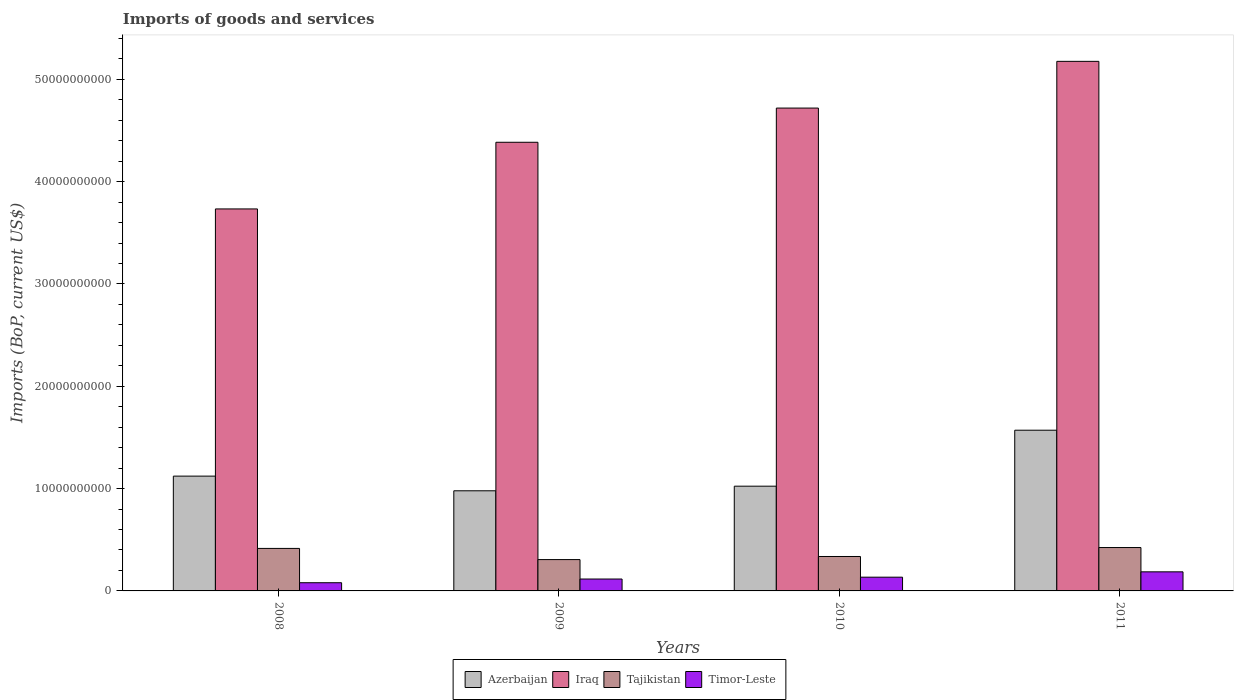How many groups of bars are there?
Provide a succinct answer. 4. Are the number of bars per tick equal to the number of legend labels?
Your response must be concise. Yes. Are the number of bars on each tick of the X-axis equal?
Make the answer very short. Yes. What is the label of the 4th group of bars from the left?
Your answer should be compact. 2011. In how many cases, is the number of bars for a given year not equal to the number of legend labels?
Provide a short and direct response. 0. What is the amount spent on imports in Tajikistan in 2008?
Make the answer very short. 4.15e+09. Across all years, what is the maximum amount spent on imports in Azerbaijan?
Your response must be concise. 1.57e+1. Across all years, what is the minimum amount spent on imports in Azerbaijan?
Your response must be concise. 9.79e+09. In which year was the amount spent on imports in Iraq minimum?
Your response must be concise. 2008. What is the total amount spent on imports in Tajikistan in the graph?
Ensure brevity in your answer.  1.48e+1. What is the difference between the amount spent on imports in Timor-Leste in 2009 and that in 2011?
Your answer should be compact. -7.03e+08. What is the difference between the amount spent on imports in Tajikistan in 2011 and the amount spent on imports in Azerbaijan in 2008?
Give a very brief answer. -6.98e+09. What is the average amount spent on imports in Azerbaijan per year?
Give a very brief answer. 1.17e+1. In the year 2011, what is the difference between the amount spent on imports in Timor-Leste and amount spent on imports in Tajikistan?
Give a very brief answer. -2.37e+09. What is the ratio of the amount spent on imports in Timor-Leste in 2008 to that in 2010?
Provide a short and direct response. 0.6. Is the difference between the amount spent on imports in Timor-Leste in 2010 and 2011 greater than the difference between the amount spent on imports in Tajikistan in 2010 and 2011?
Offer a very short reply. Yes. What is the difference between the highest and the second highest amount spent on imports in Tajikistan?
Give a very brief answer. 8.48e+07. What is the difference between the highest and the lowest amount spent on imports in Azerbaijan?
Your answer should be compact. 5.92e+09. In how many years, is the amount spent on imports in Iraq greater than the average amount spent on imports in Iraq taken over all years?
Your response must be concise. 2. Is it the case that in every year, the sum of the amount spent on imports in Iraq and amount spent on imports in Azerbaijan is greater than the sum of amount spent on imports in Tajikistan and amount spent on imports in Timor-Leste?
Provide a short and direct response. Yes. What does the 2nd bar from the left in 2011 represents?
Provide a succinct answer. Iraq. What does the 3rd bar from the right in 2010 represents?
Your response must be concise. Iraq. Are all the bars in the graph horizontal?
Your response must be concise. No. Are the values on the major ticks of Y-axis written in scientific E-notation?
Your response must be concise. No. Does the graph contain any zero values?
Keep it short and to the point. No. Where does the legend appear in the graph?
Your answer should be compact. Bottom center. How many legend labels are there?
Offer a terse response. 4. What is the title of the graph?
Offer a very short reply. Imports of goods and services. Does "Kiribati" appear as one of the legend labels in the graph?
Give a very brief answer. No. What is the label or title of the Y-axis?
Make the answer very short. Imports (BoP, current US$). What is the Imports (BoP, current US$) in Azerbaijan in 2008?
Your answer should be compact. 1.12e+1. What is the Imports (BoP, current US$) of Iraq in 2008?
Your response must be concise. 3.73e+1. What is the Imports (BoP, current US$) in Tajikistan in 2008?
Offer a terse response. 4.15e+09. What is the Imports (BoP, current US$) in Timor-Leste in 2008?
Offer a terse response. 8.01e+08. What is the Imports (BoP, current US$) in Azerbaijan in 2009?
Your response must be concise. 9.79e+09. What is the Imports (BoP, current US$) of Iraq in 2009?
Offer a very short reply. 4.38e+1. What is the Imports (BoP, current US$) in Tajikistan in 2009?
Your response must be concise. 3.06e+09. What is the Imports (BoP, current US$) in Timor-Leste in 2009?
Your answer should be compact. 1.16e+09. What is the Imports (BoP, current US$) of Azerbaijan in 2010?
Offer a very short reply. 1.02e+1. What is the Imports (BoP, current US$) of Iraq in 2010?
Provide a succinct answer. 4.72e+1. What is the Imports (BoP, current US$) in Tajikistan in 2010?
Your response must be concise. 3.36e+09. What is the Imports (BoP, current US$) of Timor-Leste in 2010?
Offer a terse response. 1.34e+09. What is the Imports (BoP, current US$) of Azerbaijan in 2011?
Provide a succinct answer. 1.57e+1. What is the Imports (BoP, current US$) in Iraq in 2011?
Offer a terse response. 5.18e+1. What is the Imports (BoP, current US$) in Tajikistan in 2011?
Your answer should be very brief. 4.24e+09. What is the Imports (BoP, current US$) of Timor-Leste in 2011?
Offer a very short reply. 1.87e+09. Across all years, what is the maximum Imports (BoP, current US$) of Azerbaijan?
Keep it short and to the point. 1.57e+1. Across all years, what is the maximum Imports (BoP, current US$) of Iraq?
Provide a short and direct response. 5.18e+1. Across all years, what is the maximum Imports (BoP, current US$) in Tajikistan?
Give a very brief answer. 4.24e+09. Across all years, what is the maximum Imports (BoP, current US$) of Timor-Leste?
Offer a terse response. 1.87e+09. Across all years, what is the minimum Imports (BoP, current US$) in Azerbaijan?
Keep it short and to the point. 9.79e+09. Across all years, what is the minimum Imports (BoP, current US$) of Iraq?
Ensure brevity in your answer.  3.73e+1. Across all years, what is the minimum Imports (BoP, current US$) of Tajikistan?
Keep it short and to the point. 3.06e+09. Across all years, what is the minimum Imports (BoP, current US$) of Timor-Leste?
Your answer should be compact. 8.01e+08. What is the total Imports (BoP, current US$) in Azerbaijan in the graph?
Offer a terse response. 4.70e+1. What is the total Imports (BoP, current US$) of Iraq in the graph?
Offer a very short reply. 1.80e+11. What is the total Imports (BoP, current US$) of Tajikistan in the graph?
Offer a terse response. 1.48e+1. What is the total Imports (BoP, current US$) in Timor-Leste in the graph?
Offer a very short reply. 5.17e+09. What is the difference between the Imports (BoP, current US$) in Azerbaijan in 2008 and that in 2009?
Offer a terse response. 1.43e+09. What is the difference between the Imports (BoP, current US$) in Iraq in 2008 and that in 2009?
Provide a succinct answer. -6.51e+09. What is the difference between the Imports (BoP, current US$) in Tajikistan in 2008 and that in 2009?
Your answer should be very brief. 1.09e+09. What is the difference between the Imports (BoP, current US$) of Timor-Leste in 2008 and that in 2009?
Offer a very short reply. -3.62e+08. What is the difference between the Imports (BoP, current US$) of Azerbaijan in 2008 and that in 2010?
Offer a terse response. 9.84e+08. What is the difference between the Imports (BoP, current US$) in Iraq in 2008 and that in 2010?
Provide a succinct answer. -9.86e+09. What is the difference between the Imports (BoP, current US$) of Tajikistan in 2008 and that in 2010?
Provide a succinct answer. 7.90e+08. What is the difference between the Imports (BoP, current US$) of Timor-Leste in 2008 and that in 2010?
Your answer should be compact. -5.42e+08. What is the difference between the Imports (BoP, current US$) of Azerbaijan in 2008 and that in 2011?
Give a very brief answer. -4.49e+09. What is the difference between the Imports (BoP, current US$) in Iraq in 2008 and that in 2011?
Offer a very short reply. -1.44e+1. What is the difference between the Imports (BoP, current US$) in Tajikistan in 2008 and that in 2011?
Offer a very short reply. -8.48e+07. What is the difference between the Imports (BoP, current US$) in Timor-Leste in 2008 and that in 2011?
Your answer should be compact. -1.06e+09. What is the difference between the Imports (BoP, current US$) of Azerbaijan in 2009 and that in 2010?
Offer a very short reply. -4.49e+08. What is the difference between the Imports (BoP, current US$) in Iraq in 2009 and that in 2010?
Your answer should be compact. -3.34e+09. What is the difference between the Imports (BoP, current US$) of Tajikistan in 2009 and that in 2010?
Offer a terse response. -3.02e+08. What is the difference between the Imports (BoP, current US$) of Timor-Leste in 2009 and that in 2010?
Your answer should be compact. -1.80e+08. What is the difference between the Imports (BoP, current US$) in Azerbaijan in 2009 and that in 2011?
Provide a short and direct response. -5.92e+09. What is the difference between the Imports (BoP, current US$) of Iraq in 2009 and that in 2011?
Keep it short and to the point. -7.91e+09. What is the difference between the Imports (BoP, current US$) in Tajikistan in 2009 and that in 2011?
Offer a terse response. -1.18e+09. What is the difference between the Imports (BoP, current US$) of Timor-Leste in 2009 and that in 2011?
Offer a very short reply. -7.03e+08. What is the difference between the Imports (BoP, current US$) of Azerbaijan in 2010 and that in 2011?
Your answer should be very brief. -5.47e+09. What is the difference between the Imports (BoP, current US$) in Iraq in 2010 and that in 2011?
Your response must be concise. -4.57e+09. What is the difference between the Imports (BoP, current US$) in Tajikistan in 2010 and that in 2011?
Offer a terse response. -8.75e+08. What is the difference between the Imports (BoP, current US$) of Timor-Leste in 2010 and that in 2011?
Offer a terse response. -5.23e+08. What is the difference between the Imports (BoP, current US$) in Azerbaijan in 2008 and the Imports (BoP, current US$) in Iraq in 2009?
Provide a short and direct response. -3.26e+1. What is the difference between the Imports (BoP, current US$) in Azerbaijan in 2008 and the Imports (BoP, current US$) in Tajikistan in 2009?
Provide a short and direct response. 8.16e+09. What is the difference between the Imports (BoP, current US$) of Azerbaijan in 2008 and the Imports (BoP, current US$) of Timor-Leste in 2009?
Make the answer very short. 1.01e+1. What is the difference between the Imports (BoP, current US$) of Iraq in 2008 and the Imports (BoP, current US$) of Tajikistan in 2009?
Make the answer very short. 3.43e+1. What is the difference between the Imports (BoP, current US$) in Iraq in 2008 and the Imports (BoP, current US$) in Timor-Leste in 2009?
Make the answer very short. 3.62e+1. What is the difference between the Imports (BoP, current US$) of Tajikistan in 2008 and the Imports (BoP, current US$) of Timor-Leste in 2009?
Make the answer very short. 2.99e+09. What is the difference between the Imports (BoP, current US$) in Azerbaijan in 2008 and the Imports (BoP, current US$) in Iraq in 2010?
Your response must be concise. -3.60e+1. What is the difference between the Imports (BoP, current US$) of Azerbaijan in 2008 and the Imports (BoP, current US$) of Tajikistan in 2010?
Offer a very short reply. 7.86e+09. What is the difference between the Imports (BoP, current US$) of Azerbaijan in 2008 and the Imports (BoP, current US$) of Timor-Leste in 2010?
Keep it short and to the point. 9.88e+09. What is the difference between the Imports (BoP, current US$) of Iraq in 2008 and the Imports (BoP, current US$) of Tajikistan in 2010?
Ensure brevity in your answer.  3.40e+1. What is the difference between the Imports (BoP, current US$) of Iraq in 2008 and the Imports (BoP, current US$) of Timor-Leste in 2010?
Provide a short and direct response. 3.60e+1. What is the difference between the Imports (BoP, current US$) of Tajikistan in 2008 and the Imports (BoP, current US$) of Timor-Leste in 2010?
Keep it short and to the point. 2.81e+09. What is the difference between the Imports (BoP, current US$) of Azerbaijan in 2008 and the Imports (BoP, current US$) of Iraq in 2011?
Provide a short and direct response. -4.05e+1. What is the difference between the Imports (BoP, current US$) in Azerbaijan in 2008 and the Imports (BoP, current US$) in Tajikistan in 2011?
Offer a very short reply. 6.98e+09. What is the difference between the Imports (BoP, current US$) in Azerbaijan in 2008 and the Imports (BoP, current US$) in Timor-Leste in 2011?
Make the answer very short. 9.36e+09. What is the difference between the Imports (BoP, current US$) of Iraq in 2008 and the Imports (BoP, current US$) of Tajikistan in 2011?
Provide a short and direct response. 3.31e+1. What is the difference between the Imports (BoP, current US$) in Iraq in 2008 and the Imports (BoP, current US$) in Timor-Leste in 2011?
Keep it short and to the point. 3.55e+1. What is the difference between the Imports (BoP, current US$) in Tajikistan in 2008 and the Imports (BoP, current US$) in Timor-Leste in 2011?
Your answer should be very brief. 2.29e+09. What is the difference between the Imports (BoP, current US$) in Azerbaijan in 2009 and the Imports (BoP, current US$) in Iraq in 2010?
Your answer should be compact. -3.74e+1. What is the difference between the Imports (BoP, current US$) of Azerbaijan in 2009 and the Imports (BoP, current US$) of Tajikistan in 2010?
Give a very brief answer. 6.42e+09. What is the difference between the Imports (BoP, current US$) in Azerbaijan in 2009 and the Imports (BoP, current US$) in Timor-Leste in 2010?
Ensure brevity in your answer.  8.44e+09. What is the difference between the Imports (BoP, current US$) of Iraq in 2009 and the Imports (BoP, current US$) of Tajikistan in 2010?
Make the answer very short. 4.05e+1. What is the difference between the Imports (BoP, current US$) in Iraq in 2009 and the Imports (BoP, current US$) in Timor-Leste in 2010?
Give a very brief answer. 4.25e+1. What is the difference between the Imports (BoP, current US$) of Tajikistan in 2009 and the Imports (BoP, current US$) of Timor-Leste in 2010?
Provide a short and direct response. 1.72e+09. What is the difference between the Imports (BoP, current US$) of Azerbaijan in 2009 and the Imports (BoP, current US$) of Iraq in 2011?
Ensure brevity in your answer.  -4.20e+1. What is the difference between the Imports (BoP, current US$) of Azerbaijan in 2009 and the Imports (BoP, current US$) of Tajikistan in 2011?
Offer a terse response. 5.55e+09. What is the difference between the Imports (BoP, current US$) of Azerbaijan in 2009 and the Imports (BoP, current US$) of Timor-Leste in 2011?
Keep it short and to the point. 7.92e+09. What is the difference between the Imports (BoP, current US$) in Iraq in 2009 and the Imports (BoP, current US$) in Tajikistan in 2011?
Provide a short and direct response. 3.96e+1. What is the difference between the Imports (BoP, current US$) of Iraq in 2009 and the Imports (BoP, current US$) of Timor-Leste in 2011?
Your response must be concise. 4.20e+1. What is the difference between the Imports (BoP, current US$) in Tajikistan in 2009 and the Imports (BoP, current US$) in Timor-Leste in 2011?
Your answer should be compact. 1.20e+09. What is the difference between the Imports (BoP, current US$) in Azerbaijan in 2010 and the Imports (BoP, current US$) in Iraq in 2011?
Provide a short and direct response. -4.15e+1. What is the difference between the Imports (BoP, current US$) in Azerbaijan in 2010 and the Imports (BoP, current US$) in Tajikistan in 2011?
Your response must be concise. 6.00e+09. What is the difference between the Imports (BoP, current US$) of Azerbaijan in 2010 and the Imports (BoP, current US$) of Timor-Leste in 2011?
Give a very brief answer. 8.37e+09. What is the difference between the Imports (BoP, current US$) of Iraq in 2010 and the Imports (BoP, current US$) of Tajikistan in 2011?
Give a very brief answer. 4.30e+1. What is the difference between the Imports (BoP, current US$) in Iraq in 2010 and the Imports (BoP, current US$) in Timor-Leste in 2011?
Give a very brief answer. 4.53e+1. What is the difference between the Imports (BoP, current US$) in Tajikistan in 2010 and the Imports (BoP, current US$) in Timor-Leste in 2011?
Your answer should be compact. 1.50e+09. What is the average Imports (BoP, current US$) of Azerbaijan per year?
Provide a short and direct response. 1.17e+1. What is the average Imports (BoP, current US$) in Iraq per year?
Your answer should be very brief. 4.50e+1. What is the average Imports (BoP, current US$) of Tajikistan per year?
Offer a very short reply. 3.71e+09. What is the average Imports (BoP, current US$) of Timor-Leste per year?
Make the answer very short. 1.29e+09. In the year 2008, what is the difference between the Imports (BoP, current US$) in Azerbaijan and Imports (BoP, current US$) in Iraq?
Your answer should be compact. -2.61e+1. In the year 2008, what is the difference between the Imports (BoP, current US$) in Azerbaijan and Imports (BoP, current US$) in Tajikistan?
Offer a very short reply. 7.07e+09. In the year 2008, what is the difference between the Imports (BoP, current US$) of Azerbaijan and Imports (BoP, current US$) of Timor-Leste?
Offer a terse response. 1.04e+1. In the year 2008, what is the difference between the Imports (BoP, current US$) of Iraq and Imports (BoP, current US$) of Tajikistan?
Give a very brief answer. 3.32e+1. In the year 2008, what is the difference between the Imports (BoP, current US$) of Iraq and Imports (BoP, current US$) of Timor-Leste?
Provide a short and direct response. 3.65e+1. In the year 2008, what is the difference between the Imports (BoP, current US$) in Tajikistan and Imports (BoP, current US$) in Timor-Leste?
Make the answer very short. 3.35e+09. In the year 2009, what is the difference between the Imports (BoP, current US$) in Azerbaijan and Imports (BoP, current US$) in Iraq?
Your answer should be very brief. -3.41e+1. In the year 2009, what is the difference between the Imports (BoP, current US$) in Azerbaijan and Imports (BoP, current US$) in Tajikistan?
Your answer should be very brief. 6.72e+09. In the year 2009, what is the difference between the Imports (BoP, current US$) of Azerbaijan and Imports (BoP, current US$) of Timor-Leste?
Give a very brief answer. 8.62e+09. In the year 2009, what is the difference between the Imports (BoP, current US$) in Iraq and Imports (BoP, current US$) in Tajikistan?
Provide a short and direct response. 4.08e+1. In the year 2009, what is the difference between the Imports (BoP, current US$) of Iraq and Imports (BoP, current US$) of Timor-Leste?
Keep it short and to the point. 4.27e+1. In the year 2009, what is the difference between the Imports (BoP, current US$) of Tajikistan and Imports (BoP, current US$) of Timor-Leste?
Keep it short and to the point. 1.90e+09. In the year 2010, what is the difference between the Imports (BoP, current US$) in Azerbaijan and Imports (BoP, current US$) in Iraq?
Offer a terse response. -3.70e+1. In the year 2010, what is the difference between the Imports (BoP, current US$) of Azerbaijan and Imports (BoP, current US$) of Tajikistan?
Offer a terse response. 6.87e+09. In the year 2010, what is the difference between the Imports (BoP, current US$) in Azerbaijan and Imports (BoP, current US$) in Timor-Leste?
Your response must be concise. 8.89e+09. In the year 2010, what is the difference between the Imports (BoP, current US$) of Iraq and Imports (BoP, current US$) of Tajikistan?
Provide a short and direct response. 4.38e+1. In the year 2010, what is the difference between the Imports (BoP, current US$) in Iraq and Imports (BoP, current US$) in Timor-Leste?
Ensure brevity in your answer.  4.58e+1. In the year 2010, what is the difference between the Imports (BoP, current US$) of Tajikistan and Imports (BoP, current US$) of Timor-Leste?
Provide a short and direct response. 2.02e+09. In the year 2011, what is the difference between the Imports (BoP, current US$) of Azerbaijan and Imports (BoP, current US$) of Iraq?
Provide a short and direct response. -3.60e+1. In the year 2011, what is the difference between the Imports (BoP, current US$) of Azerbaijan and Imports (BoP, current US$) of Tajikistan?
Ensure brevity in your answer.  1.15e+1. In the year 2011, what is the difference between the Imports (BoP, current US$) of Azerbaijan and Imports (BoP, current US$) of Timor-Leste?
Provide a succinct answer. 1.38e+1. In the year 2011, what is the difference between the Imports (BoP, current US$) of Iraq and Imports (BoP, current US$) of Tajikistan?
Keep it short and to the point. 4.75e+1. In the year 2011, what is the difference between the Imports (BoP, current US$) in Iraq and Imports (BoP, current US$) in Timor-Leste?
Keep it short and to the point. 4.99e+1. In the year 2011, what is the difference between the Imports (BoP, current US$) in Tajikistan and Imports (BoP, current US$) in Timor-Leste?
Offer a very short reply. 2.37e+09. What is the ratio of the Imports (BoP, current US$) in Azerbaijan in 2008 to that in 2009?
Ensure brevity in your answer.  1.15. What is the ratio of the Imports (BoP, current US$) of Iraq in 2008 to that in 2009?
Ensure brevity in your answer.  0.85. What is the ratio of the Imports (BoP, current US$) in Tajikistan in 2008 to that in 2009?
Keep it short and to the point. 1.36. What is the ratio of the Imports (BoP, current US$) in Timor-Leste in 2008 to that in 2009?
Offer a terse response. 0.69. What is the ratio of the Imports (BoP, current US$) in Azerbaijan in 2008 to that in 2010?
Offer a very short reply. 1.1. What is the ratio of the Imports (BoP, current US$) of Iraq in 2008 to that in 2010?
Offer a very short reply. 0.79. What is the ratio of the Imports (BoP, current US$) in Tajikistan in 2008 to that in 2010?
Your answer should be compact. 1.23. What is the ratio of the Imports (BoP, current US$) of Timor-Leste in 2008 to that in 2010?
Provide a short and direct response. 0.6. What is the ratio of the Imports (BoP, current US$) of Azerbaijan in 2008 to that in 2011?
Your response must be concise. 0.71. What is the ratio of the Imports (BoP, current US$) in Iraq in 2008 to that in 2011?
Your answer should be compact. 0.72. What is the ratio of the Imports (BoP, current US$) in Tajikistan in 2008 to that in 2011?
Offer a terse response. 0.98. What is the ratio of the Imports (BoP, current US$) in Timor-Leste in 2008 to that in 2011?
Make the answer very short. 0.43. What is the ratio of the Imports (BoP, current US$) in Azerbaijan in 2009 to that in 2010?
Provide a short and direct response. 0.96. What is the ratio of the Imports (BoP, current US$) in Iraq in 2009 to that in 2010?
Your response must be concise. 0.93. What is the ratio of the Imports (BoP, current US$) in Tajikistan in 2009 to that in 2010?
Your answer should be very brief. 0.91. What is the ratio of the Imports (BoP, current US$) of Timor-Leste in 2009 to that in 2010?
Your answer should be compact. 0.87. What is the ratio of the Imports (BoP, current US$) of Azerbaijan in 2009 to that in 2011?
Offer a terse response. 0.62. What is the ratio of the Imports (BoP, current US$) of Iraq in 2009 to that in 2011?
Offer a terse response. 0.85. What is the ratio of the Imports (BoP, current US$) of Tajikistan in 2009 to that in 2011?
Offer a terse response. 0.72. What is the ratio of the Imports (BoP, current US$) in Timor-Leste in 2009 to that in 2011?
Offer a very short reply. 0.62. What is the ratio of the Imports (BoP, current US$) of Azerbaijan in 2010 to that in 2011?
Provide a short and direct response. 0.65. What is the ratio of the Imports (BoP, current US$) of Iraq in 2010 to that in 2011?
Your response must be concise. 0.91. What is the ratio of the Imports (BoP, current US$) of Tajikistan in 2010 to that in 2011?
Your answer should be compact. 0.79. What is the ratio of the Imports (BoP, current US$) in Timor-Leste in 2010 to that in 2011?
Keep it short and to the point. 0.72. What is the difference between the highest and the second highest Imports (BoP, current US$) in Azerbaijan?
Make the answer very short. 4.49e+09. What is the difference between the highest and the second highest Imports (BoP, current US$) in Iraq?
Give a very brief answer. 4.57e+09. What is the difference between the highest and the second highest Imports (BoP, current US$) in Tajikistan?
Offer a very short reply. 8.48e+07. What is the difference between the highest and the second highest Imports (BoP, current US$) in Timor-Leste?
Make the answer very short. 5.23e+08. What is the difference between the highest and the lowest Imports (BoP, current US$) of Azerbaijan?
Give a very brief answer. 5.92e+09. What is the difference between the highest and the lowest Imports (BoP, current US$) of Iraq?
Your answer should be compact. 1.44e+1. What is the difference between the highest and the lowest Imports (BoP, current US$) in Tajikistan?
Your answer should be very brief. 1.18e+09. What is the difference between the highest and the lowest Imports (BoP, current US$) in Timor-Leste?
Provide a short and direct response. 1.06e+09. 